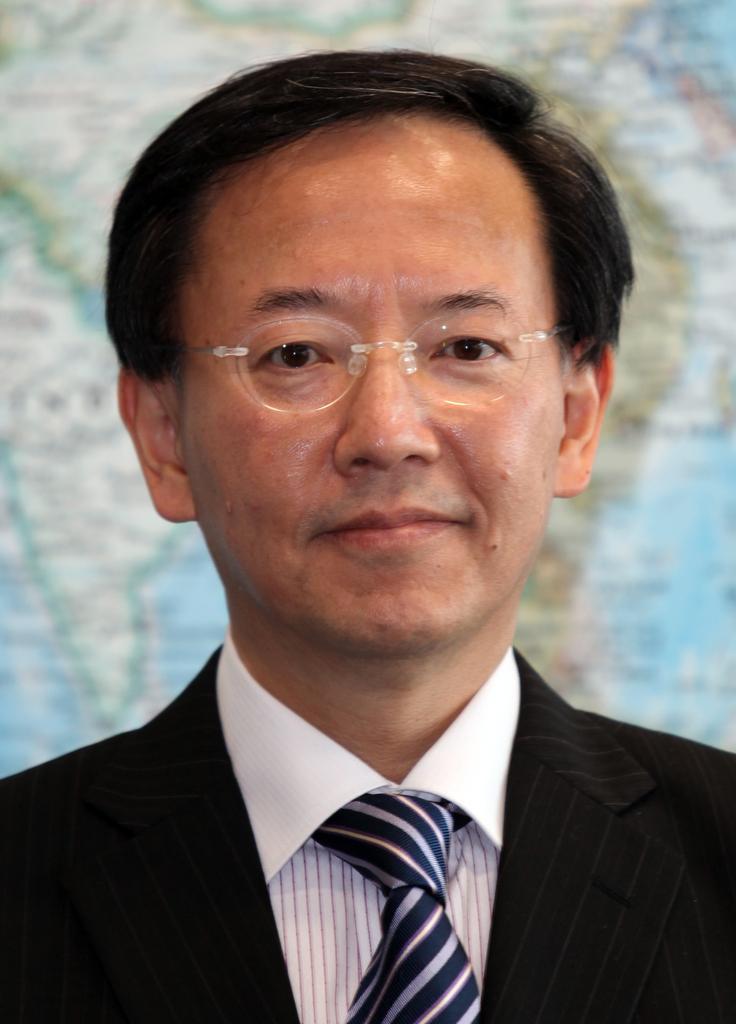In one or two sentences, can you explain what this image depicts? This image consists of a man wearing a black suit along with a tie. In the background, we can see a map. He is wearing a spectacle. 